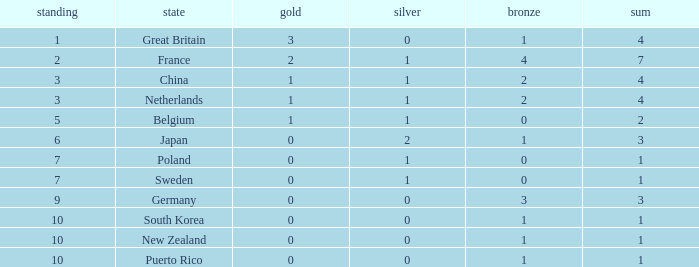Could you parse the entire table? {'header': ['standing', 'state', 'gold', 'silver', 'bronze', 'sum'], 'rows': [['1', 'Great Britain', '3', '0', '1', '4'], ['2', 'France', '2', '1', '4', '7'], ['3', 'China', '1', '1', '2', '4'], ['3', 'Netherlands', '1', '1', '2', '4'], ['5', 'Belgium', '1', '1', '0', '2'], ['6', 'Japan', '0', '2', '1', '3'], ['7', 'Poland', '0', '1', '0', '1'], ['7', 'Sweden', '0', '1', '0', '1'], ['9', 'Germany', '0', '0', '3', '3'], ['10', 'South Korea', '0', '0', '1', '1'], ['10', 'New Zealand', '0', '0', '1', '1'], ['10', 'Puerto Rico', '0', '0', '1', '1']]} What is the smallest number of gold where the total is less than 3 and the silver count is 2? None. 